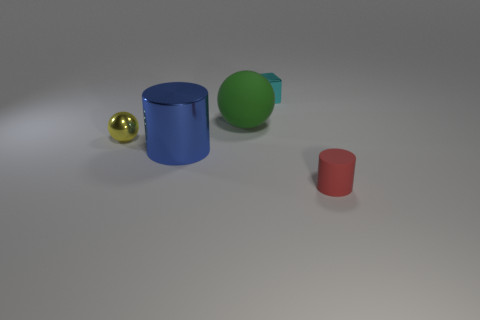The cylinder behind the tiny matte thing is what color?
Ensure brevity in your answer.  Blue. What number of cubes are either tiny cyan shiny things or red objects?
Offer a terse response. 1. What size is the blue object in front of the matte object that is behind the yellow sphere?
Your answer should be compact. Large. What number of blue metallic cylinders are in front of the cyan metal object?
Ensure brevity in your answer.  1. Are there fewer tiny blue rubber balls than small yellow balls?
Provide a succinct answer. Yes. There is a thing that is both to the right of the blue cylinder and left of the cyan metallic block; how big is it?
Provide a succinct answer. Large. Is the number of tiny shiny balls to the right of the large metallic cylinder less than the number of cylinders?
Offer a very short reply. Yes. There is a tiny red object that is the same material as the green sphere; what shape is it?
Offer a very short reply. Cylinder. Are the small ball and the large blue object made of the same material?
Make the answer very short. Yes. Is the number of blue things right of the red thing less than the number of tiny rubber objects that are behind the small cyan metal object?
Keep it short and to the point. No. 